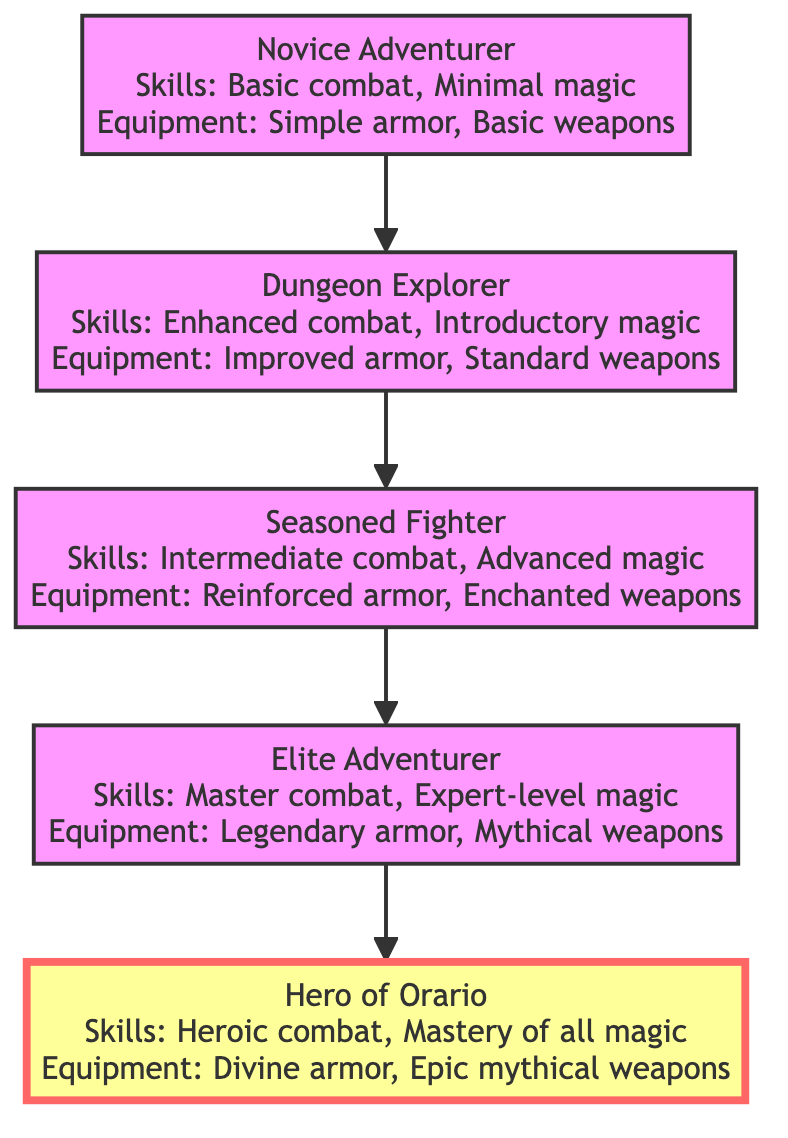What is the highest level of character development shown? The diagram lists "Hero of Orario" as the last element in the flow, which represents the highest level of character development in the progression.
Answer: Hero of Orario How many character development stages are depicted? By counting the numbered nodes from "Novice Adventurer" to "Hero of Orario," we find there are five distinct stages in the character development progression.
Answer: 5 What type of armor does a Seasoned Fighter wear? Referring to the "Seasoned Fighter" node, it mentions that the equipment includes "Reinforced armor," indicating the type of armor a Seasoned Fighter possesses.
Answer: Reinforced armor What skills does an Elite Adventurer have? The "Elite Adventurer" node details that this character possesses "Master combat techniques" and "Expert-level magic spells," which are the skills attributed to this stage.
Answer: Master combat techniques, Expert-level magic spells Which element is directly above Dungeon Explorer? Tracing the arrows upward from the "Dungeon Explorer" node leads to "Seasoned Fighter," indicating that this is the next level in the progression directly above Dungeon Explorer.
Answer: Seasoned Fighter What equipment does a Novice Adventurer use? The "Novice Adventurer" node lists the equipment as "Simple armor" and "Basic weapons," specifically detailing what a Novice Adventurer possesses at this initial stage.
Answer: Simple armor, Basic weapons What is the main distinction between an Elite Adventurer and a Hero of Orario? The comparison reveals that while an "Elite Adventurer" wields "Legendary armor" and has "Exceptional skills," the "Hero of Orario" has "Divine armor" and achieves "Heroic combat proficiency," signifying advancement in skill and equipment.
Answer: Divine armor, Epic mythical weapons How does one progress from Novice Adventurer to Dungeon Explorer? The diagram indicates a direct connection (arrow) going from "Novice Adventurer" to "Dungeon Explorer," showing that progress from the Novice stage leads to becoming a Dungeon Explorer.
Answer: By gaining experience What kind of magic skills does a Hero of Orario possess? The "Hero of Orario" node describes that the character has "Mastery of all magic," summarizing the highest level of magical skill achieved within the progression.
Answer: Mastery of all magic 